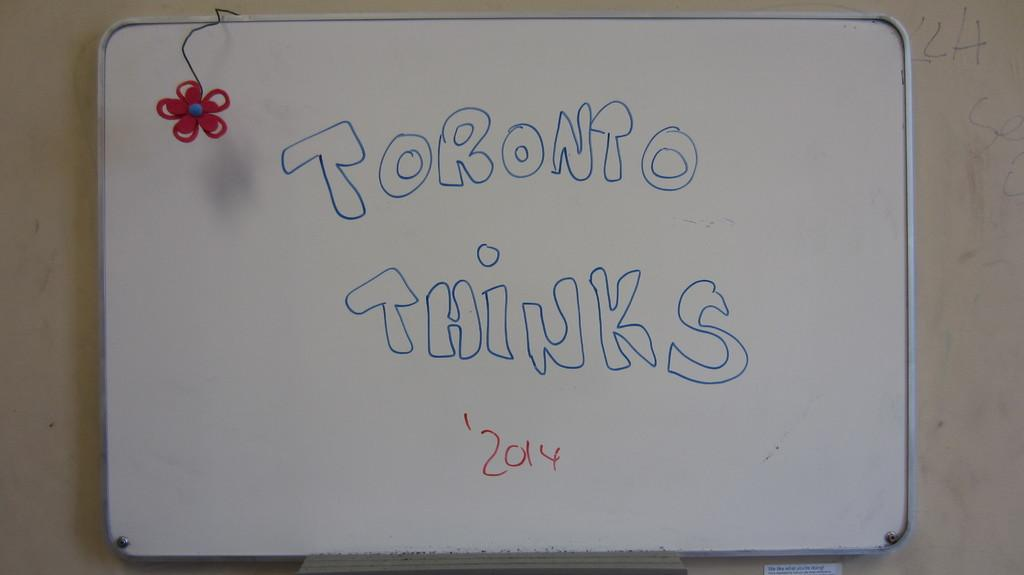<image>
Relay a brief, clear account of the picture shown. White board with the words Toronto Thinks in blue on it. 